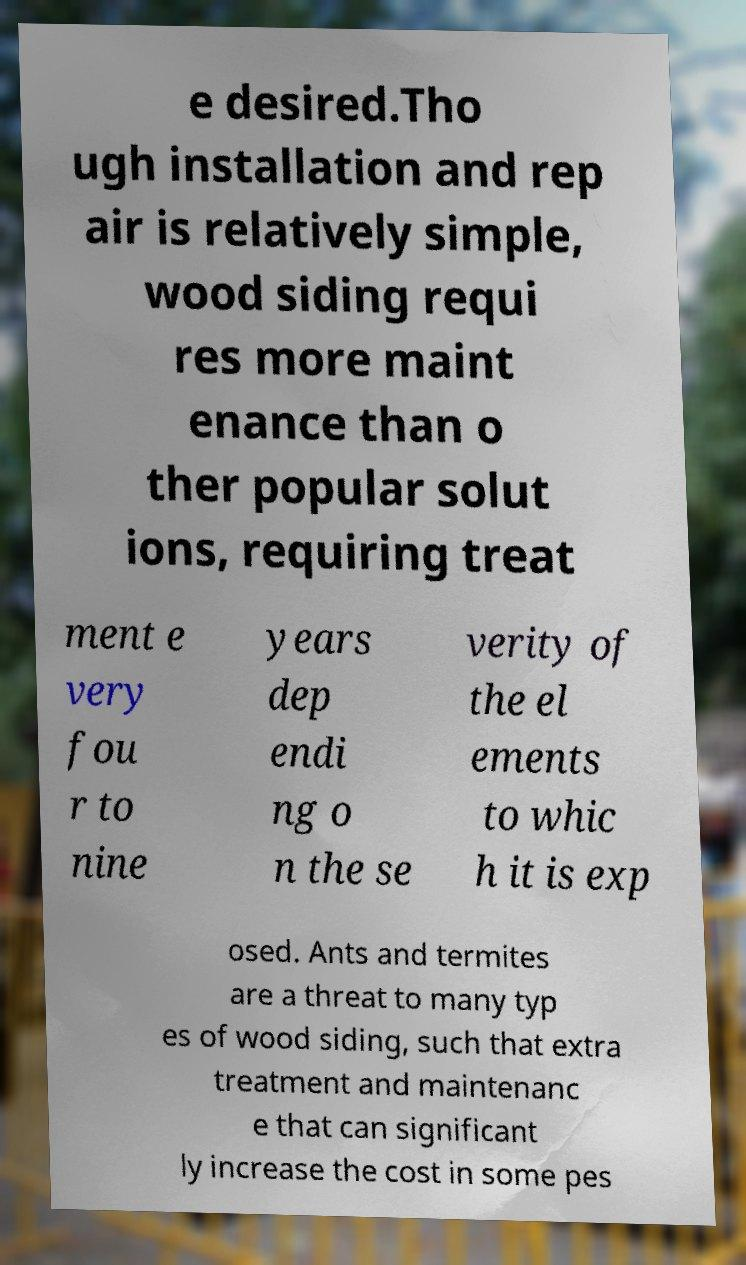For documentation purposes, I need the text within this image transcribed. Could you provide that? e desired.Tho ugh installation and rep air is relatively simple, wood siding requi res more maint enance than o ther popular solut ions, requiring treat ment e very fou r to nine years dep endi ng o n the se verity of the el ements to whic h it is exp osed. Ants and termites are a threat to many typ es of wood siding, such that extra treatment and maintenanc e that can significant ly increase the cost in some pes 